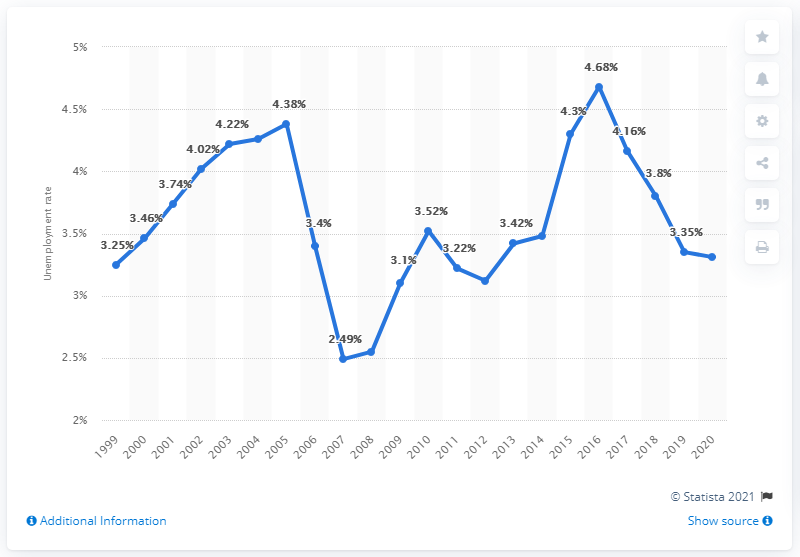Can you explain the trend in unemployment rates in Norway from 2019 to 2020? Certainly. The graph indicates a rise in unemployment rates from 2019 to 2020. The rate was at 3.7% in 2019 and climbed to 5.4% in 2020. This uptick likely reflects the economic fallout from the pandemic, which affected industries and employment worldwide. 